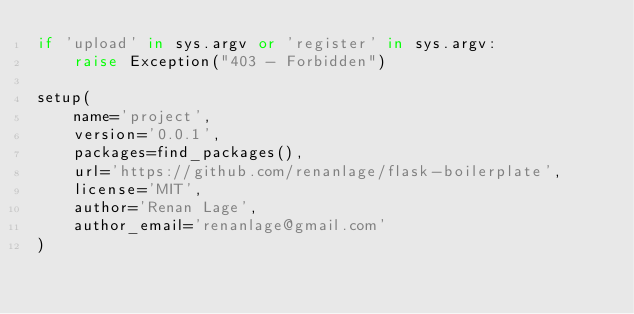Convert code to text. <code><loc_0><loc_0><loc_500><loc_500><_Python_>if 'upload' in sys.argv or 'register' in sys.argv:
    raise Exception("403 - Forbidden")

setup(
    name='project',
    version='0.0.1',
    packages=find_packages(),
    url='https://github.com/renanlage/flask-boilerplate',
    license='MIT',
    author='Renan Lage',
    author_email='renanlage@gmail.com'
)
</code> 